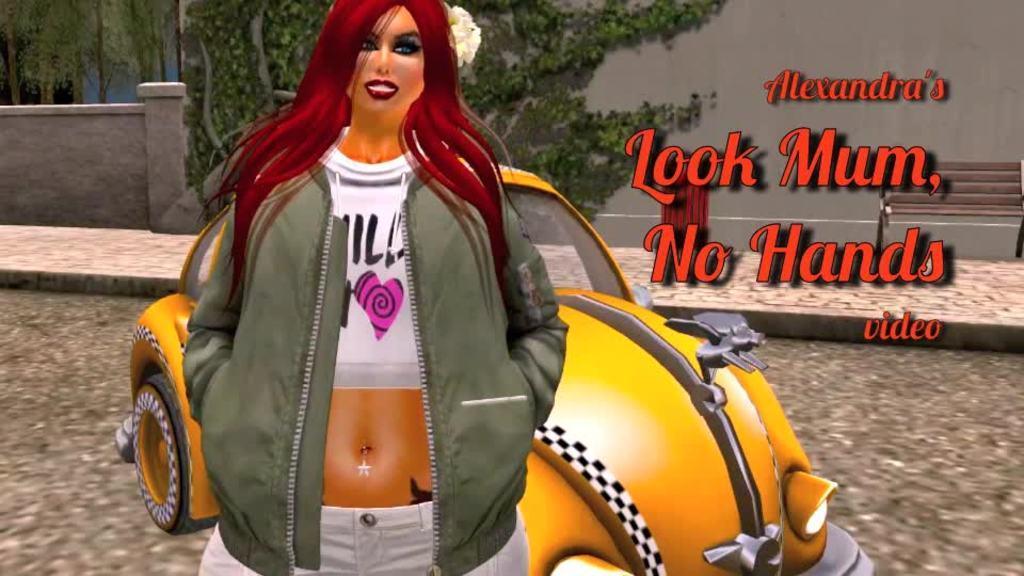Describe this image in one or two sentences. This is an animated picture. In the center of the picture there is a woman and a car behind her. Towards right there is text. In the background of there are trees, wall, bench dustbin and footpath. 